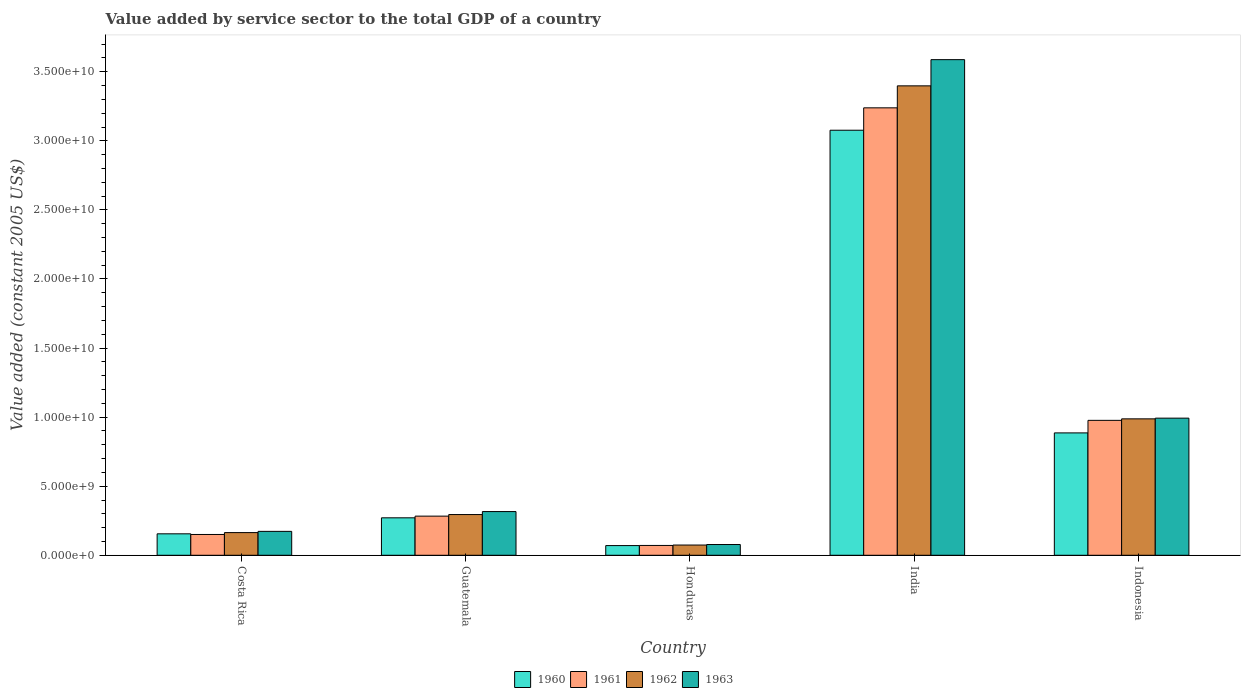Are the number of bars per tick equal to the number of legend labels?
Your response must be concise. Yes. How many bars are there on the 3rd tick from the right?
Keep it short and to the point. 4. What is the label of the 3rd group of bars from the left?
Your answer should be compact. Honduras. In how many cases, is the number of bars for a given country not equal to the number of legend labels?
Provide a succinct answer. 0. What is the value added by service sector in 1960 in Honduras?
Make the answer very short. 7.01e+08. Across all countries, what is the maximum value added by service sector in 1963?
Your answer should be very brief. 3.59e+1. Across all countries, what is the minimum value added by service sector in 1963?
Your answer should be compact. 7.78e+08. In which country was the value added by service sector in 1960 maximum?
Offer a terse response. India. In which country was the value added by service sector in 1960 minimum?
Ensure brevity in your answer.  Honduras. What is the total value added by service sector in 1962 in the graph?
Provide a short and direct response. 4.92e+1. What is the difference between the value added by service sector in 1962 in Guatemala and that in Honduras?
Keep it short and to the point. 2.21e+09. What is the difference between the value added by service sector in 1963 in Honduras and the value added by service sector in 1961 in Guatemala?
Make the answer very short. -2.06e+09. What is the average value added by service sector in 1963 per country?
Offer a terse response. 1.03e+1. What is the difference between the value added by service sector of/in 1963 and value added by service sector of/in 1962 in India?
Make the answer very short. 1.90e+09. What is the ratio of the value added by service sector in 1962 in Guatemala to that in Indonesia?
Ensure brevity in your answer.  0.3. What is the difference between the highest and the second highest value added by service sector in 1963?
Offer a very short reply. 2.60e+1. What is the difference between the highest and the lowest value added by service sector in 1961?
Provide a succinct answer. 3.17e+1. In how many countries, is the value added by service sector in 1961 greater than the average value added by service sector in 1961 taken over all countries?
Your response must be concise. 2. Is it the case that in every country, the sum of the value added by service sector in 1960 and value added by service sector in 1963 is greater than the sum of value added by service sector in 1961 and value added by service sector in 1962?
Your answer should be very brief. No. What does the 2nd bar from the left in Indonesia represents?
Make the answer very short. 1961. Is it the case that in every country, the sum of the value added by service sector in 1963 and value added by service sector in 1962 is greater than the value added by service sector in 1960?
Ensure brevity in your answer.  Yes. How many bars are there?
Ensure brevity in your answer.  20. Are all the bars in the graph horizontal?
Keep it short and to the point. No. Are the values on the major ticks of Y-axis written in scientific E-notation?
Make the answer very short. Yes. Does the graph contain any zero values?
Give a very brief answer. No. Does the graph contain grids?
Offer a terse response. No. Where does the legend appear in the graph?
Your answer should be very brief. Bottom center. What is the title of the graph?
Your answer should be compact. Value added by service sector to the total GDP of a country. Does "1962" appear as one of the legend labels in the graph?
Offer a terse response. Yes. What is the label or title of the Y-axis?
Offer a very short reply. Value added (constant 2005 US$). What is the Value added (constant 2005 US$) in 1960 in Costa Rica?
Offer a very short reply. 1.55e+09. What is the Value added (constant 2005 US$) of 1961 in Costa Rica?
Your answer should be compact. 1.51e+09. What is the Value added (constant 2005 US$) in 1962 in Costa Rica?
Give a very brief answer. 1.64e+09. What is the Value added (constant 2005 US$) in 1963 in Costa Rica?
Provide a succinct answer. 1.73e+09. What is the Value added (constant 2005 US$) of 1960 in Guatemala?
Your response must be concise. 2.71e+09. What is the Value added (constant 2005 US$) in 1961 in Guatemala?
Your answer should be very brief. 2.83e+09. What is the Value added (constant 2005 US$) in 1962 in Guatemala?
Offer a terse response. 2.95e+09. What is the Value added (constant 2005 US$) in 1963 in Guatemala?
Ensure brevity in your answer.  3.16e+09. What is the Value added (constant 2005 US$) in 1960 in Honduras?
Provide a short and direct response. 7.01e+08. What is the Value added (constant 2005 US$) of 1961 in Honduras?
Your response must be concise. 7.12e+08. What is the Value added (constant 2005 US$) in 1962 in Honduras?
Provide a short and direct response. 7.41e+08. What is the Value added (constant 2005 US$) of 1963 in Honduras?
Provide a short and direct response. 7.78e+08. What is the Value added (constant 2005 US$) of 1960 in India?
Your answer should be very brief. 3.08e+1. What is the Value added (constant 2005 US$) of 1961 in India?
Keep it short and to the point. 3.24e+1. What is the Value added (constant 2005 US$) of 1962 in India?
Offer a very short reply. 3.40e+1. What is the Value added (constant 2005 US$) in 1963 in India?
Offer a terse response. 3.59e+1. What is the Value added (constant 2005 US$) of 1960 in Indonesia?
Provide a short and direct response. 8.86e+09. What is the Value added (constant 2005 US$) in 1961 in Indonesia?
Offer a terse response. 9.77e+09. What is the Value added (constant 2005 US$) in 1962 in Indonesia?
Your response must be concise. 9.88e+09. What is the Value added (constant 2005 US$) of 1963 in Indonesia?
Your response must be concise. 9.93e+09. Across all countries, what is the maximum Value added (constant 2005 US$) in 1960?
Offer a very short reply. 3.08e+1. Across all countries, what is the maximum Value added (constant 2005 US$) of 1961?
Offer a very short reply. 3.24e+1. Across all countries, what is the maximum Value added (constant 2005 US$) in 1962?
Your answer should be compact. 3.40e+1. Across all countries, what is the maximum Value added (constant 2005 US$) in 1963?
Ensure brevity in your answer.  3.59e+1. Across all countries, what is the minimum Value added (constant 2005 US$) in 1960?
Your response must be concise. 7.01e+08. Across all countries, what is the minimum Value added (constant 2005 US$) in 1961?
Ensure brevity in your answer.  7.12e+08. Across all countries, what is the minimum Value added (constant 2005 US$) in 1962?
Provide a succinct answer. 7.41e+08. Across all countries, what is the minimum Value added (constant 2005 US$) in 1963?
Provide a short and direct response. 7.78e+08. What is the total Value added (constant 2005 US$) of 1960 in the graph?
Give a very brief answer. 4.46e+1. What is the total Value added (constant 2005 US$) in 1961 in the graph?
Give a very brief answer. 4.72e+1. What is the total Value added (constant 2005 US$) of 1962 in the graph?
Your answer should be compact. 4.92e+1. What is the total Value added (constant 2005 US$) in 1963 in the graph?
Your answer should be very brief. 5.15e+1. What is the difference between the Value added (constant 2005 US$) in 1960 in Costa Rica and that in Guatemala?
Provide a succinct answer. -1.16e+09. What is the difference between the Value added (constant 2005 US$) of 1961 in Costa Rica and that in Guatemala?
Make the answer very short. -1.33e+09. What is the difference between the Value added (constant 2005 US$) of 1962 in Costa Rica and that in Guatemala?
Your response must be concise. -1.31e+09. What is the difference between the Value added (constant 2005 US$) of 1963 in Costa Rica and that in Guatemala?
Your answer should be very brief. -1.43e+09. What is the difference between the Value added (constant 2005 US$) of 1960 in Costa Rica and that in Honduras?
Provide a short and direct response. 8.51e+08. What is the difference between the Value added (constant 2005 US$) in 1961 in Costa Rica and that in Honduras?
Keep it short and to the point. 7.94e+08. What is the difference between the Value added (constant 2005 US$) in 1962 in Costa Rica and that in Honduras?
Your answer should be compact. 9.01e+08. What is the difference between the Value added (constant 2005 US$) in 1963 in Costa Rica and that in Honduras?
Your answer should be compact. 9.53e+08. What is the difference between the Value added (constant 2005 US$) in 1960 in Costa Rica and that in India?
Your response must be concise. -2.92e+1. What is the difference between the Value added (constant 2005 US$) of 1961 in Costa Rica and that in India?
Keep it short and to the point. -3.09e+1. What is the difference between the Value added (constant 2005 US$) of 1962 in Costa Rica and that in India?
Provide a succinct answer. -3.23e+1. What is the difference between the Value added (constant 2005 US$) of 1963 in Costa Rica and that in India?
Offer a very short reply. -3.41e+1. What is the difference between the Value added (constant 2005 US$) in 1960 in Costa Rica and that in Indonesia?
Your response must be concise. -7.31e+09. What is the difference between the Value added (constant 2005 US$) of 1961 in Costa Rica and that in Indonesia?
Provide a succinct answer. -8.26e+09. What is the difference between the Value added (constant 2005 US$) in 1962 in Costa Rica and that in Indonesia?
Give a very brief answer. -8.23e+09. What is the difference between the Value added (constant 2005 US$) in 1963 in Costa Rica and that in Indonesia?
Your response must be concise. -8.20e+09. What is the difference between the Value added (constant 2005 US$) of 1960 in Guatemala and that in Honduras?
Offer a very short reply. 2.01e+09. What is the difference between the Value added (constant 2005 US$) in 1961 in Guatemala and that in Honduras?
Provide a succinct answer. 2.12e+09. What is the difference between the Value added (constant 2005 US$) of 1962 in Guatemala and that in Honduras?
Offer a terse response. 2.21e+09. What is the difference between the Value added (constant 2005 US$) of 1963 in Guatemala and that in Honduras?
Make the answer very short. 2.39e+09. What is the difference between the Value added (constant 2005 US$) of 1960 in Guatemala and that in India?
Offer a very short reply. -2.81e+1. What is the difference between the Value added (constant 2005 US$) of 1961 in Guatemala and that in India?
Offer a very short reply. -2.96e+1. What is the difference between the Value added (constant 2005 US$) in 1962 in Guatemala and that in India?
Provide a succinct answer. -3.10e+1. What is the difference between the Value added (constant 2005 US$) in 1963 in Guatemala and that in India?
Your answer should be very brief. -3.27e+1. What is the difference between the Value added (constant 2005 US$) of 1960 in Guatemala and that in Indonesia?
Ensure brevity in your answer.  -6.15e+09. What is the difference between the Value added (constant 2005 US$) of 1961 in Guatemala and that in Indonesia?
Keep it short and to the point. -6.93e+09. What is the difference between the Value added (constant 2005 US$) in 1962 in Guatemala and that in Indonesia?
Your answer should be compact. -6.93e+09. What is the difference between the Value added (constant 2005 US$) of 1963 in Guatemala and that in Indonesia?
Offer a terse response. -6.76e+09. What is the difference between the Value added (constant 2005 US$) of 1960 in Honduras and that in India?
Ensure brevity in your answer.  -3.01e+1. What is the difference between the Value added (constant 2005 US$) in 1961 in Honduras and that in India?
Offer a very short reply. -3.17e+1. What is the difference between the Value added (constant 2005 US$) in 1962 in Honduras and that in India?
Provide a succinct answer. -3.32e+1. What is the difference between the Value added (constant 2005 US$) of 1963 in Honduras and that in India?
Provide a succinct answer. -3.51e+1. What is the difference between the Value added (constant 2005 US$) of 1960 in Honduras and that in Indonesia?
Your answer should be very brief. -8.16e+09. What is the difference between the Value added (constant 2005 US$) of 1961 in Honduras and that in Indonesia?
Provide a succinct answer. -9.05e+09. What is the difference between the Value added (constant 2005 US$) of 1962 in Honduras and that in Indonesia?
Make the answer very short. -9.13e+09. What is the difference between the Value added (constant 2005 US$) in 1963 in Honduras and that in Indonesia?
Your answer should be compact. -9.15e+09. What is the difference between the Value added (constant 2005 US$) of 1960 in India and that in Indonesia?
Your answer should be very brief. 2.19e+1. What is the difference between the Value added (constant 2005 US$) of 1961 in India and that in Indonesia?
Offer a terse response. 2.26e+1. What is the difference between the Value added (constant 2005 US$) of 1962 in India and that in Indonesia?
Offer a terse response. 2.41e+1. What is the difference between the Value added (constant 2005 US$) in 1963 in India and that in Indonesia?
Your answer should be very brief. 2.60e+1. What is the difference between the Value added (constant 2005 US$) of 1960 in Costa Rica and the Value added (constant 2005 US$) of 1961 in Guatemala?
Give a very brief answer. -1.28e+09. What is the difference between the Value added (constant 2005 US$) of 1960 in Costa Rica and the Value added (constant 2005 US$) of 1962 in Guatemala?
Ensure brevity in your answer.  -1.39e+09. What is the difference between the Value added (constant 2005 US$) of 1960 in Costa Rica and the Value added (constant 2005 US$) of 1963 in Guatemala?
Ensure brevity in your answer.  -1.61e+09. What is the difference between the Value added (constant 2005 US$) of 1961 in Costa Rica and the Value added (constant 2005 US$) of 1962 in Guatemala?
Keep it short and to the point. -1.44e+09. What is the difference between the Value added (constant 2005 US$) of 1961 in Costa Rica and the Value added (constant 2005 US$) of 1963 in Guatemala?
Make the answer very short. -1.66e+09. What is the difference between the Value added (constant 2005 US$) of 1962 in Costa Rica and the Value added (constant 2005 US$) of 1963 in Guatemala?
Keep it short and to the point. -1.52e+09. What is the difference between the Value added (constant 2005 US$) in 1960 in Costa Rica and the Value added (constant 2005 US$) in 1961 in Honduras?
Keep it short and to the point. 8.41e+08. What is the difference between the Value added (constant 2005 US$) in 1960 in Costa Rica and the Value added (constant 2005 US$) in 1962 in Honduras?
Offer a very short reply. 8.12e+08. What is the difference between the Value added (constant 2005 US$) in 1960 in Costa Rica and the Value added (constant 2005 US$) in 1963 in Honduras?
Your answer should be very brief. 7.75e+08. What is the difference between the Value added (constant 2005 US$) in 1961 in Costa Rica and the Value added (constant 2005 US$) in 1962 in Honduras?
Give a very brief answer. 7.65e+08. What is the difference between the Value added (constant 2005 US$) in 1961 in Costa Rica and the Value added (constant 2005 US$) in 1963 in Honduras?
Offer a very short reply. 7.28e+08. What is the difference between the Value added (constant 2005 US$) in 1962 in Costa Rica and the Value added (constant 2005 US$) in 1963 in Honduras?
Provide a short and direct response. 8.63e+08. What is the difference between the Value added (constant 2005 US$) in 1960 in Costa Rica and the Value added (constant 2005 US$) in 1961 in India?
Your answer should be very brief. -3.08e+1. What is the difference between the Value added (constant 2005 US$) in 1960 in Costa Rica and the Value added (constant 2005 US$) in 1962 in India?
Ensure brevity in your answer.  -3.24e+1. What is the difference between the Value added (constant 2005 US$) in 1960 in Costa Rica and the Value added (constant 2005 US$) in 1963 in India?
Your answer should be very brief. -3.43e+1. What is the difference between the Value added (constant 2005 US$) in 1961 in Costa Rica and the Value added (constant 2005 US$) in 1962 in India?
Your answer should be very brief. -3.25e+1. What is the difference between the Value added (constant 2005 US$) of 1961 in Costa Rica and the Value added (constant 2005 US$) of 1963 in India?
Ensure brevity in your answer.  -3.44e+1. What is the difference between the Value added (constant 2005 US$) of 1962 in Costa Rica and the Value added (constant 2005 US$) of 1963 in India?
Provide a succinct answer. -3.42e+1. What is the difference between the Value added (constant 2005 US$) of 1960 in Costa Rica and the Value added (constant 2005 US$) of 1961 in Indonesia?
Provide a succinct answer. -8.21e+09. What is the difference between the Value added (constant 2005 US$) of 1960 in Costa Rica and the Value added (constant 2005 US$) of 1962 in Indonesia?
Ensure brevity in your answer.  -8.32e+09. What is the difference between the Value added (constant 2005 US$) of 1960 in Costa Rica and the Value added (constant 2005 US$) of 1963 in Indonesia?
Provide a short and direct response. -8.37e+09. What is the difference between the Value added (constant 2005 US$) of 1961 in Costa Rica and the Value added (constant 2005 US$) of 1962 in Indonesia?
Provide a succinct answer. -8.37e+09. What is the difference between the Value added (constant 2005 US$) of 1961 in Costa Rica and the Value added (constant 2005 US$) of 1963 in Indonesia?
Keep it short and to the point. -8.42e+09. What is the difference between the Value added (constant 2005 US$) in 1962 in Costa Rica and the Value added (constant 2005 US$) in 1963 in Indonesia?
Your answer should be compact. -8.29e+09. What is the difference between the Value added (constant 2005 US$) of 1960 in Guatemala and the Value added (constant 2005 US$) of 1961 in Honduras?
Offer a very short reply. 2.00e+09. What is the difference between the Value added (constant 2005 US$) of 1960 in Guatemala and the Value added (constant 2005 US$) of 1962 in Honduras?
Give a very brief answer. 1.97e+09. What is the difference between the Value added (constant 2005 US$) of 1960 in Guatemala and the Value added (constant 2005 US$) of 1963 in Honduras?
Your answer should be very brief. 1.93e+09. What is the difference between the Value added (constant 2005 US$) in 1961 in Guatemala and the Value added (constant 2005 US$) in 1962 in Honduras?
Make the answer very short. 2.09e+09. What is the difference between the Value added (constant 2005 US$) of 1961 in Guatemala and the Value added (constant 2005 US$) of 1963 in Honduras?
Offer a very short reply. 2.06e+09. What is the difference between the Value added (constant 2005 US$) of 1962 in Guatemala and the Value added (constant 2005 US$) of 1963 in Honduras?
Offer a very short reply. 2.17e+09. What is the difference between the Value added (constant 2005 US$) of 1960 in Guatemala and the Value added (constant 2005 US$) of 1961 in India?
Make the answer very short. -2.97e+1. What is the difference between the Value added (constant 2005 US$) in 1960 in Guatemala and the Value added (constant 2005 US$) in 1962 in India?
Your response must be concise. -3.13e+1. What is the difference between the Value added (constant 2005 US$) in 1960 in Guatemala and the Value added (constant 2005 US$) in 1963 in India?
Your answer should be very brief. -3.32e+1. What is the difference between the Value added (constant 2005 US$) in 1961 in Guatemala and the Value added (constant 2005 US$) in 1962 in India?
Keep it short and to the point. -3.11e+1. What is the difference between the Value added (constant 2005 US$) in 1961 in Guatemala and the Value added (constant 2005 US$) in 1963 in India?
Your answer should be compact. -3.30e+1. What is the difference between the Value added (constant 2005 US$) in 1962 in Guatemala and the Value added (constant 2005 US$) in 1963 in India?
Give a very brief answer. -3.29e+1. What is the difference between the Value added (constant 2005 US$) of 1960 in Guatemala and the Value added (constant 2005 US$) of 1961 in Indonesia?
Ensure brevity in your answer.  -7.05e+09. What is the difference between the Value added (constant 2005 US$) in 1960 in Guatemala and the Value added (constant 2005 US$) in 1962 in Indonesia?
Offer a very short reply. -7.16e+09. What is the difference between the Value added (constant 2005 US$) in 1960 in Guatemala and the Value added (constant 2005 US$) in 1963 in Indonesia?
Your answer should be compact. -7.21e+09. What is the difference between the Value added (constant 2005 US$) of 1961 in Guatemala and the Value added (constant 2005 US$) of 1962 in Indonesia?
Offer a terse response. -7.04e+09. What is the difference between the Value added (constant 2005 US$) of 1961 in Guatemala and the Value added (constant 2005 US$) of 1963 in Indonesia?
Give a very brief answer. -7.09e+09. What is the difference between the Value added (constant 2005 US$) of 1962 in Guatemala and the Value added (constant 2005 US$) of 1963 in Indonesia?
Keep it short and to the point. -6.98e+09. What is the difference between the Value added (constant 2005 US$) in 1960 in Honduras and the Value added (constant 2005 US$) in 1961 in India?
Your answer should be compact. -3.17e+1. What is the difference between the Value added (constant 2005 US$) of 1960 in Honduras and the Value added (constant 2005 US$) of 1962 in India?
Provide a short and direct response. -3.33e+1. What is the difference between the Value added (constant 2005 US$) of 1960 in Honduras and the Value added (constant 2005 US$) of 1963 in India?
Ensure brevity in your answer.  -3.52e+1. What is the difference between the Value added (constant 2005 US$) of 1961 in Honduras and the Value added (constant 2005 US$) of 1962 in India?
Offer a terse response. -3.33e+1. What is the difference between the Value added (constant 2005 US$) in 1961 in Honduras and the Value added (constant 2005 US$) in 1963 in India?
Your answer should be very brief. -3.52e+1. What is the difference between the Value added (constant 2005 US$) of 1962 in Honduras and the Value added (constant 2005 US$) of 1963 in India?
Make the answer very short. -3.51e+1. What is the difference between the Value added (constant 2005 US$) of 1960 in Honduras and the Value added (constant 2005 US$) of 1961 in Indonesia?
Offer a terse response. -9.07e+09. What is the difference between the Value added (constant 2005 US$) of 1960 in Honduras and the Value added (constant 2005 US$) of 1962 in Indonesia?
Give a very brief answer. -9.17e+09. What is the difference between the Value added (constant 2005 US$) in 1960 in Honduras and the Value added (constant 2005 US$) in 1963 in Indonesia?
Your response must be concise. -9.23e+09. What is the difference between the Value added (constant 2005 US$) of 1961 in Honduras and the Value added (constant 2005 US$) of 1962 in Indonesia?
Make the answer very short. -9.16e+09. What is the difference between the Value added (constant 2005 US$) in 1961 in Honduras and the Value added (constant 2005 US$) in 1963 in Indonesia?
Your answer should be very brief. -9.22e+09. What is the difference between the Value added (constant 2005 US$) in 1962 in Honduras and the Value added (constant 2005 US$) in 1963 in Indonesia?
Offer a terse response. -9.19e+09. What is the difference between the Value added (constant 2005 US$) in 1960 in India and the Value added (constant 2005 US$) in 1961 in Indonesia?
Your answer should be very brief. 2.10e+1. What is the difference between the Value added (constant 2005 US$) in 1960 in India and the Value added (constant 2005 US$) in 1962 in Indonesia?
Your answer should be compact. 2.09e+1. What is the difference between the Value added (constant 2005 US$) in 1960 in India and the Value added (constant 2005 US$) in 1963 in Indonesia?
Give a very brief answer. 2.08e+1. What is the difference between the Value added (constant 2005 US$) in 1961 in India and the Value added (constant 2005 US$) in 1962 in Indonesia?
Ensure brevity in your answer.  2.25e+1. What is the difference between the Value added (constant 2005 US$) in 1961 in India and the Value added (constant 2005 US$) in 1963 in Indonesia?
Your answer should be very brief. 2.25e+1. What is the difference between the Value added (constant 2005 US$) in 1962 in India and the Value added (constant 2005 US$) in 1963 in Indonesia?
Make the answer very short. 2.41e+1. What is the average Value added (constant 2005 US$) of 1960 per country?
Ensure brevity in your answer.  8.92e+09. What is the average Value added (constant 2005 US$) of 1961 per country?
Make the answer very short. 9.44e+09. What is the average Value added (constant 2005 US$) of 1962 per country?
Ensure brevity in your answer.  9.84e+09. What is the average Value added (constant 2005 US$) of 1963 per country?
Provide a short and direct response. 1.03e+1. What is the difference between the Value added (constant 2005 US$) in 1960 and Value added (constant 2005 US$) in 1961 in Costa Rica?
Provide a short and direct response. 4.72e+07. What is the difference between the Value added (constant 2005 US$) in 1960 and Value added (constant 2005 US$) in 1962 in Costa Rica?
Offer a terse response. -8.87e+07. What is the difference between the Value added (constant 2005 US$) in 1960 and Value added (constant 2005 US$) in 1963 in Costa Rica?
Your answer should be compact. -1.78e+08. What is the difference between the Value added (constant 2005 US$) of 1961 and Value added (constant 2005 US$) of 1962 in Costa Rica?
Keep it short and to the point. -1.36e+08. What is the difference between the Value added (constant 2005 US$) of 1961 and Value added (constant 2005 US$) of 1963 in Costa Rica?
Make the answer very short. -2.25e+08. What is the difference between the Value added (constant 2005 US$) of 1962 and Value added (constant 2005 US$) of 1963 in Costa Rica?
Keep it short and to the point. -8.94e+07. What is the difference between the Value added (constant 2005 US$) in 1960 and Value added (constant 2005 US$) in 1961 in Guatemala?
Your answer should be very brief. -1.22e+08. What is the difference between the Value added (constant 2005 US$) of 1960 and Value added (constant 2005 US$) of 1962 in Guatemala?
Offer a very short reply. -2.35e+08. What is the difference between the Value added (constant 2005 US$) in 1960 and Value added (constant 2005 US$) in 1963 in Guatemala?
Keep it short and to the point. -4.53e+08. What is the difference between the Value added (constant 2005 US$) in 1961 and Value added (constant 2005 US$) in 1962 in Guatemala?
Offer a terse response. -1.14e+08. What is the difference between the Value added (constant 2005 US$) in 1961 and Value added (constant 2005 US$) in 1963 in Guatemala?
Provide a short and direct response. -3.31e+08. What is the difference between the Value added (constant 2005 US$) of 1962 and Value added (constant 2005 US$) of 1963 in Guatemala?
Offer a terse response. -2.17e+08. What is the difference between the Value added (constant 2005 US$) in 1960 and Value added (constant 2005 US$) in 1961 in Honduras?
Keep it short and to the point. -1.04e+07. What is the difference between the Value added (constant 2005 US$) in 1960 and Value added (constant 2005 US$) in 1962 in Honduras?
Give a very brief answer. -3.93e+07. What is the difference between the Value added (constant 2005 US$) in 1960 and Value added (constant 2005 US$) in 1963 in Honduras?
Offer a terse response. -7.65e+07. What is the difference between the Value added (constant 2005 US$) of 1961 and Value added (constant 2005 US$) of 1962 in Honduras?
Your response must be concise. -2.89e+07. What is the difference between the Value added (constant 2005 US$) in 1961 and Value added (constant 2005 US$) in 1963 in Honduras?
Offer a terse response. -6.62e+07. What is the difference between the Value added (constant 2005 US$) of 1962 and Value added (constant 2005 US$) of 1963 in Honduras?
Your answer should be very brief. -3.72e+07. What is the difference between the Value added (constant 2005 US$) of 1960 and Value added (constant 2005 US$) of 1961 in India?
Your answer should be compact. -1.62e+09. What is the difference between the Value added (constant 2005 US$) in 1960 and Value added (constant 2005 US$) in 1962 in India?
Make the answer very short. -3.21e+09. What is the difference between the Value added (constant 2005 US$) of 1960 and Value added (constant 2005 US$) of 1963 in India?
Offer a terse response. -5.11e+09. What is the difference between the Value added (constant 2005 US$) of 1961 and Value added (constant 2005 US$) of 1962 in India?
Provide a succinct answer. -1.59e+09. What is the difference between the Value added (constant 2005 US$) of 1961 and Value added (constant 2005 US$) of 1963 in India?
Give a very brief answer. -3.49e+09. What is the difference between the Value added (constant 2005 US$) of 1962 and Value added (constant 2005 US$) of 1963 in India?
Your answer should be very brief. -1.90e+09. What is the difference between the Value added (constant 2005 US$) of 1960 and Value added (constant 2005 US$) of 1961 in Indonesia?
Keep it short and to the point. -9.08e+08. What is the difference between the Value added (constant 2005 US$) of 1960 and Value added (constant 2005 US$) of 1962 in Indonesia?
Offer a very short reply. -1.02e+09. What is the difference between the Value added (constant 2005 US$) in 1960 and Value added (constant 2005 US$) in 1963 in Indonesia?
Your answer should be compact. -1.07e+09. What is the difference between the Value added (constant 2005 US$) in 1961 and Value added (constant 2005 US$) in 1962 in Indonesia?
Your answer should be very brief. -1.09e+08. What is the difference between the Value added (constant 2005 US$) in 1961 and Value added (constant 2005 US$) in 1963 in Indonesia?
Your answer should be very brief. -1.60e+08. What is the difference between the Value added (constant 2005 US$) of 1962 and Value added (constant 2005 US$) of 1963 in Indonesia?
Your answer should be very brief. -5.15e+07. What is the ratio of the Value added (constant 2005 US$) of 1960 in Costa Rica to that in Guatemala?
Your answer should be compact. 0.57. What is the ratio of the Value added (constant 2005 US$) in 1961 in Costa Rica to that in Guatemala?
Provide a succinct answer. 0.53. What is the ratio of the Value added (constant 2005 US$) in 1962 in Costa Rica to that in Guatemala?
Offer a terse response. 0.56. What is the ratio of the Value added (constant 2005 US$) in 1963 in Costa Rica to that in Guatemala?
Your answer should be very brief. 0.55. What is the ratio of the Value added (constant 2005 US$) of 1960 in Costa Rica to that in Honduras?
Give a very brief answer. 2.21. What is the ratio of the Value added (constant 2005 US$) in 1961 in Costa Rica to that in Honduras?
Your answer should be compact. 2.12. What is the ratio of the Value added (constant 2005 US$) of 1962 in Costa Rica to that in Honduras?
Make the answer very short. 2.22. What is the ratio of the Value added (constant 2005 US$) in 1963 in Costa Rica to that in Honduras?
Keep it short and to the point. 2.23. What is the ratio of the Value added (constant 2005 US$) of 1960 in Costa Rica to that in India?
Offer a very short reply. 0.05. What is the ratio of the Value added (constant 2005 US$) in 1961 in Costa Rica to that in India?
Make the answer very short. 0.05. What is the ratio of the Value added (constant 2005 US$) in 1962 in Costa Rica to that in India?
Make the answer very short. 0.05. What is the ratio of the Value added (constant 2005 US$) in 1963 in Costa Rica to that in India?
Ensure brevity in your answer.  0.05. What is the ratio of the Value added (constant 2005 US$) in 1960 in Costa Rica to that in Indonesia?
Make the answer very short. 0.18. What is the ratio of the Value added (constant 2005 US$) of 1961 in Costa Rica to that in Indonesia?
Provide a short and direct response. 0.15. What is the ratio of the Value added (constant 2005 US$) of 1962 in Costa Rica to that in Indonesia?
Make the answer very short. 0.17. What is the ratio of the Value added (constant 2005 US$) of 1963 in Costa Rica to that in Indonesia?
Provide a short and direct response. 0.17. What is the ratio of the Value added (constant 2005 US$) of 1960 in Guatemala to that in Honduras?
Provide a succinct answer. 3.87. What is the ratio of the Value added (constant 2005 US$) in 1961 in Guatemala to that in Honduras?
Your answer should be very brief. 3.98. What is the ratio of the Value added (constant 2005 US$) in 1962 in Guatemala to that in Honduras?
Your response must be concise. 3.98. What is the ratio of the Value added (constant 2005 US$) in 1963 in Guatemala to that in Honduras?
Offer a terse response. 4.07. What is the ratio of the Value added (constant 2005 US$) in 1960 in Guatemala to that in India?
Offer a terse response. 0.09. What is the ratio of the Value added (constant 2005 US$) of 1961 in Guatemala to that in India?
Your answer should be compact. 0.09. What is the ratio of the Value added (constant 2005 US$) of 1962 in Guatemala to that in India?
Provide a short and direct response. 0.09. What is the ratio of the Value added (constant 2005 US$) in 1963 in Guatemala to that in India?
Provide a short and direct response. 0.09. What is the ratio of the Value added (constant 2005 US$) in 1960 in Guatemala to that in Indonesia?
Keep it short and to the point. 0.31. What is the ratio of the Value added (constant 2005 US$) in 1961 in Guatemala to that in Indonesia?
Ensure brevity in your answer.  0.29. What is the ratio of the Value added (constant 2005 US$) in 1962 in Guatemala to that in Indonesia?
Your answer should be very brief. 0.3. What is the ratio of the Value added (constant 2005 US$) of 1963 in Guatemala to that in Indonesia?
Ensure brevity in your answer.  0.32. What is the ratio of the Value added (constant 2005 US$) in 1960 in Honduras to that in India?
Make the answer very short. 0.02. What is the ratio of the Value added (constant 2005 US$) of 1961 in Honduras to that in India?
Your answer should be very brief. 0.02. What is the ratio of the Value added (constant 2005 US$) in 1962 in Honduras to that in India?
Offer a very short reply. 0.02. What is the ratio of the Value added (constant 2005 US$) in 1963 in Honduras to that in India?
Ensure brevity in your answer.  0.02. What is the ratio of the Value added (constant 2005 US$) in 1960 in Honduras to that in Indonesia?
Keep it short and to the point. 0.08. What is the ratio of the Value added (constant 2005 US$) in 1961 in Honduras to that in Indonesia?
Your answer should be very brief. 0.07. What is the ratio of the Value added (constant 2005 US$) of 1962 in Honduras to that in Indonesia?
Give a very brief answer. 0.07. What is the ratio of the Value added (constant 2005 US$) in 1963 in Honduras to that in Indonesia?
Your answer should be very brief. 0.08. What is the ratio of the Value added (constant 2005 US$) in 1960 in India to that in Indonesia?
Offer a very short reply. 3.47. What is the ratio of the Value added (constant 2005 US$) of 1961 in India to that in Indonesia?
Your answer should be very brief. 3.32. What is the ratio of the Value added (constant 2005 US$) of 1962 in India to that in Indonesia?
Provide a short and direct response. 3.44. What is the ratio of the Value added (constant 2005 US$) in 1963 in India to that in Indonesia?
Keep it short and to the point. 3.61. What is the difference between the highest and the second highest Value added (constant 2005 US$) of 1960?
Give a very brief answer. 2.19e+1. What is the difference between the highest and the second highest Value added (constant 2005 US$) of 1961?
Your response must be concise. 2.26e+1. What is the difference between the highest and the second highest Value added (constant 2005 US$) in 1962?
Your answer should be compact. 2.41e+1. What is the difference between the highest and the second highest Value added (constant 2005 US$) in 1963?
Provide a short and direct response. 2.60e+1. What is the difference between the highest and the lowest Value added (constant 2005 US$) of 1960?
Give a very brief answer. 3.01e+1. What is the difference between the highest and the lowest Value added (constant 2005 US$) in 1961?
Offer a terse response. 3.17e+1. What is the difference between the highest and the lowest Value added (constant 2005 US$) in 1962?
Give a very brief answer. 3.32e+1. What is the difference between the highest and the lowest Value added (constant 2005 US$) in 1963?
Offer a terse response. 3.51e+1. 